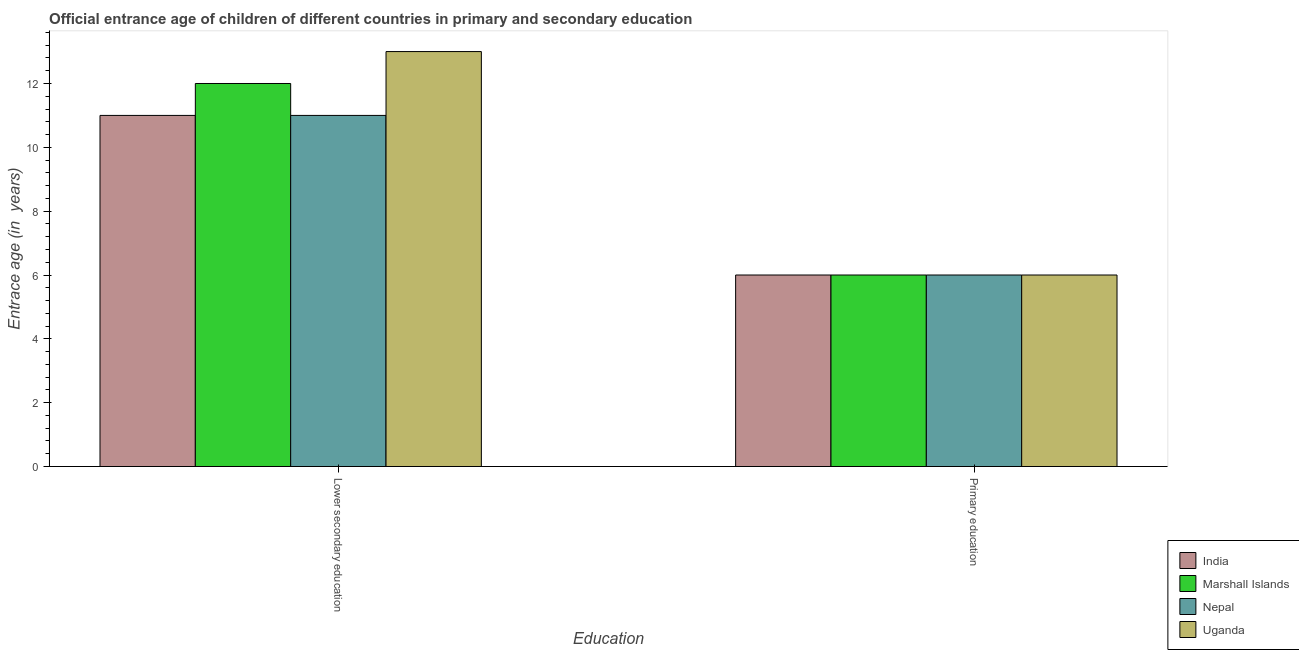How many different coloured bars are there?
Make the answer very short. 4. Are the number of bars per tick equal to the number of legend labels?
Give a very brief answer. Yes. Are the number of bars on each tick of the X-axis equal?
Make the answer very short. Yes. What is the label of the 2nd group of bars from the left?
Offer a very short reply. Primary education. What is the entrance age of children in lower secondary education in Uganda?
Keep it short and to the point. 13. Across all countries, what is the minimum entrance age of children in lower secondary education?
Offer a very short reply. 11. In which country was the entrance age of children in lower secondary education minimum?
Your answer should be very brief. India. What is the total entrance age of children in lower secondary education in the graph?
Your answer should be compact. 47. What is the difference between the entrance age of children in lower secondary education in India and that in Marshall Islands?
Your answer should be very brief. -1. What is the difference between the entrance age of chiildren in primary education in Marshall Islands and the entrance age of children in lower secondary education in India?
Provide a succinct answer. -5. What is the difference between the entrance age of chiildren in primary education and entrance age of children in lower secondary education in Uganda?
Your answer should be compact. -7. In how many countries, is the entrance age of children in lower secondary education greater than 7.6 years?
Give a very brief answer. 4. Is the entrance age of children in lower secondary education in Uganda less than that in India?
Offer a terse response. No. In how many countries, is the entrance age of chiildren in primary education greater than the average entrance age of chiildren in primary education taken over all countries?
Give a very brief answer. 0. What does the 2nd bar from the left in Primary education represents?
Your answer should be very brief. Marshall Islands. What does the 3rd bar from the right in Lower secondary education represents?
Your response must be concise. Marshall Islands. How many bars are there?
Provide a short and direct response. 8. How many countries are there in the graph?
Ensure brevity in your answer.  4. Does the graph contain any zero values?
Your answer should be compact. No. What is the title of the graph?
Provide a succinct answer. Official entrance age of children of different countries in primary and secondary education. What is the label or title of the X-axis?
Give a very brief answer. Education. What is the label or title of the Y-axis?
Your answer should be compact. Entrace age (in  years). What is the Entrace age (in  years) of Nepal in Lower secondary education?
Ensure brevity in your answer.  11. What is the Entrace age (in  years) of India in Primary education?
Provide a short and direct response. 6. What is the Entrace age (in  years) in Marshall Islands in Primary education?
Provide a succinct answer. 6. Across all Education, what is the maximum Entrace age (in  years) in India?
Ensure brevity in your answer.  11. Across all Education, what is the minimum Entrace age (in  years) in Uganda?
Offer a terse response. 6. What is the total Entrace age (in  years) in Marshall Islands in the graph?
Give a very brief answer. 18. What is the total Entrace age (in  years) in Nepal in the graph?
Offer a terse response. 17. What is the difference between the Entrace age (in  years) in Marshall Islands in Lower secondary education and that in Primary education?
Provide a succinct answer. 6. What is the difference between the Entrace age (in  years) in Nepal in Lower secondary education and that in Primary education?
Give a very brief answer. 5. What is the difference between the Entrace age (in  years) of Uganda in Lower secondary education and that in Primary education?
Provide a short and direct response. 7. What is the difference between the Entrace age (in  years) in India in Lower secondary education and the Entrace age (in  years) in Marshall Islands in Primary education?
Offer a very short reply. 5. What is the difference between the Entrace age (in  years) in India in Lower secondary education and the Entrace age (in  years) in Nepal in Primary education?
Your answer should be compact. 5. What is the difference between the Entrace age (in  years) in Nepal in Lower secondary education and the Entrace age (in  years) in Uganda in Primary education?
Provide a short and direct response. 5. What is the difference between the Entrace age (in  years) of India and Entrace age (in  years) of Nepal in Lower secondary education?
Make the answer very short. 0. What is the difference between the Entrace age (in  years) in Nepal and Entrace age (in  years) in Uganda in Lower secondary education?
Keep it short and to the point. -2. What is the difference between the Entrace age (in  years) of India and Entrace age (in  years) of Marshall Islands in Primary education?
Your answer should be compact. 0. What is the difference between the Entrace age (in  years) of India and Entrace age (in  years) of Nepal in Primary education?
Provide a short and direct response. 0. What is the difference between the Entrace age (in  years) of India and Entrace age (in  years) of Uganda in Primary education?
Your answer should be very brief. 0. What is the difference between the Entrace age (in  years) of Marshall Islands and Entrace age (in  years) of Uganda in Primary education?
Ensure brevity in your answer.  0. What is the ratio of the Entrace age (in  years) of India in Lower secondary education to that in Primary education?
Offer a very short reply. 1.83. What is the ratio of the Entrace age (in  years) in Marshall Islands in Lower secondary education to that in Primary education?
Your response must be concise. 2. What is the ratio of the Entrace age (in  years) in Nepal in Lower secondary education to that in Primary education?
Ensure brevity in your answer.  1.83. What is the ratio of the Entrace age (in  years) in Uganda in Lower secondary education to that in Primary education?
Your answer should be very brief. 2.17. What is the difference between the highest and the second highest Entrace age (in  years) of Nepal?
Offer a very short reply. 5. What is the difference between the highest and the lowest Entrace age (in  years) in Uganda?
Provide a short and direct response. 7. 